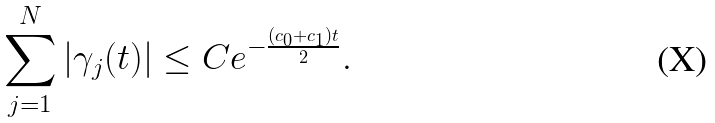<formula> <loc_0><loc_0><loc_500><loc_500>\sum _ { j = 1 } ^ { N } | \gamma _ { j } ( t ) | \leq C e ^ { - \frac { ( c _ { 0 } + c _ { 1 } ) t } { 2 } } .</formula> 